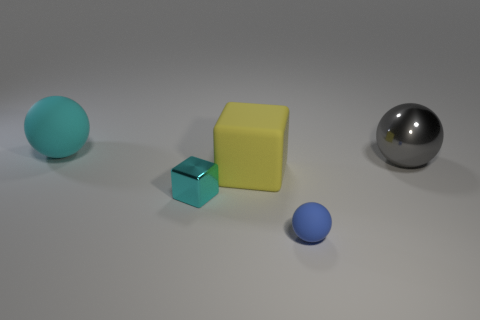There is a big cyan object left of the yellow thing; what is its material?
Give a very brief answer. Rubber. How big is the matte sphere behind the matte sphere that is in front of the large metal ball behind the blue thing?
Your response must be concise. Large. Do the cyan object to the right of the large cyan matte object and the large thing in front of the large gray thing have the same material?
Ensure brevity in your answer.  No. How many other objects are the same color as the large rubber block?
Provide a short and direct response. 0. How many objects are large spheres to the right of the large matte sphere or cyan objects in front of the large cyan rubber thing?
Provide a succinct answer. 2. What is the size of the shiny thing left of the rubber ball that is in front of the big gray metal sphere?
Offer a terse response. Small. How big is the blue rubber thing?
Offer a very short reply. Small. Does the sphere to the left of the small cyan thing have the same color as the small object left of the small matte object?
Offer a terse response. Yes. What number of other objects are the same material as the gray sphere?
Give a very brief answer. 1. Are there any metal cubes?
Your answer should be compact. Yes. 